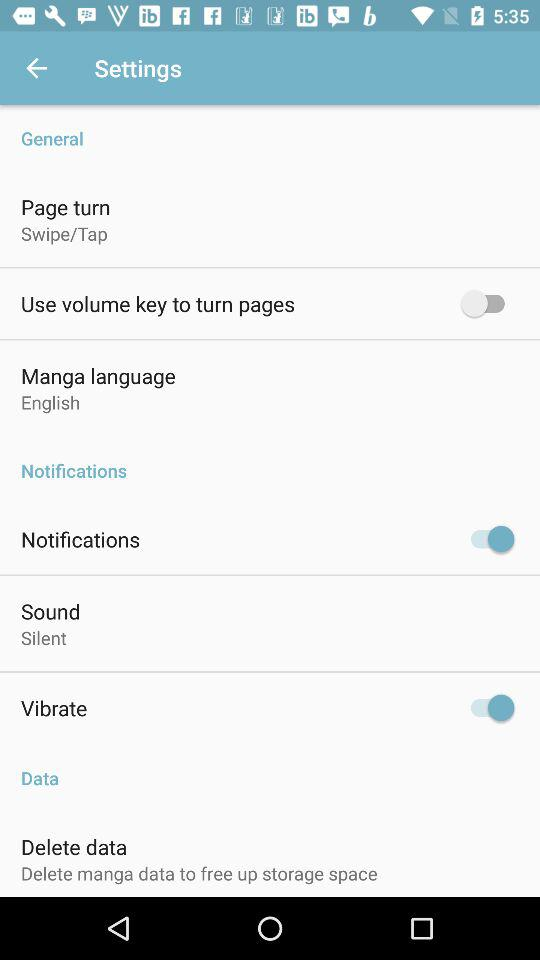What is the status of vibrate? The status is on. 